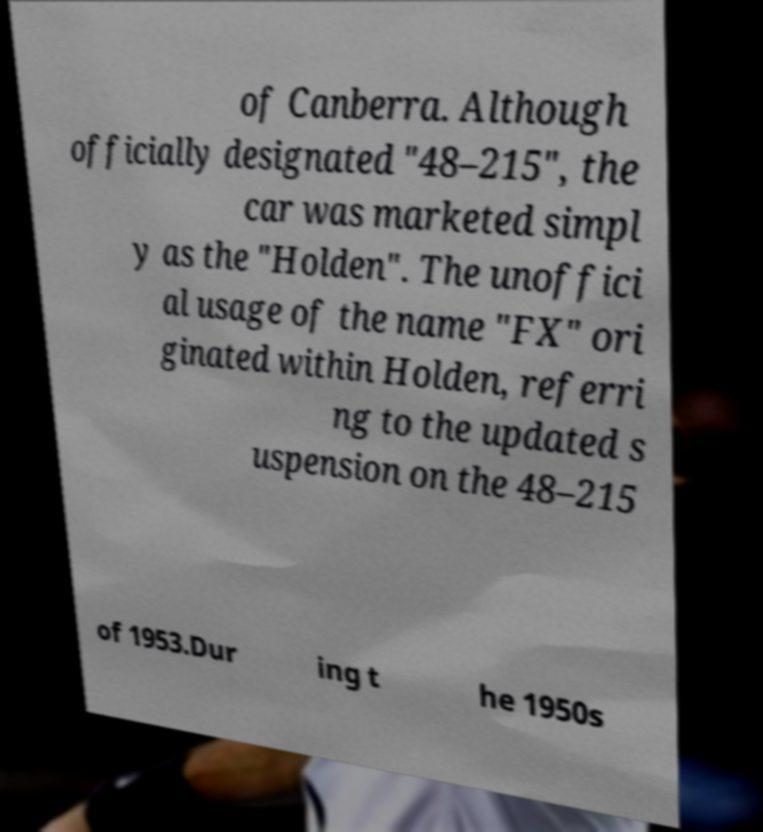Can you accurately transcribe the text from the provided image for me? of Canberra. Although officially designated "48–215", the car was marketed simpl y as the "Holden". The unoffici al usage of the name "FX" ori ginated within Holden, referri ng to the updated s uspension on the 48–215 of 1953.Dur ing t he 1950s 